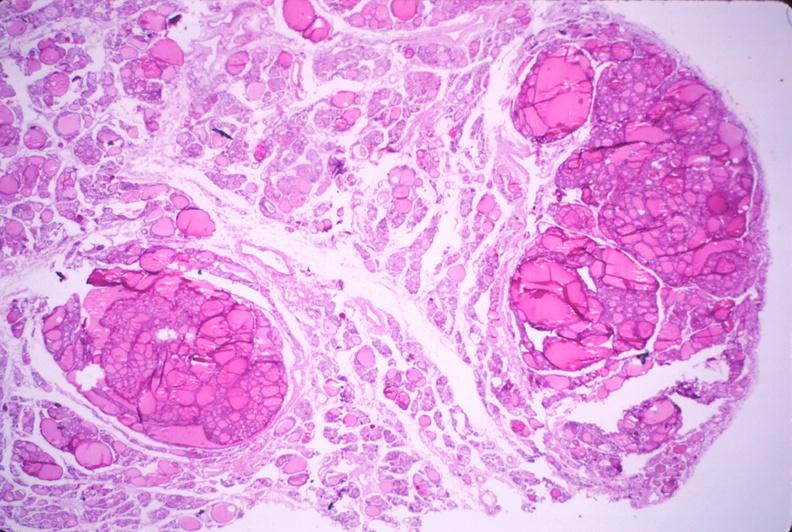what is present?
Answer the question using a single word or phrase. Endocrine 